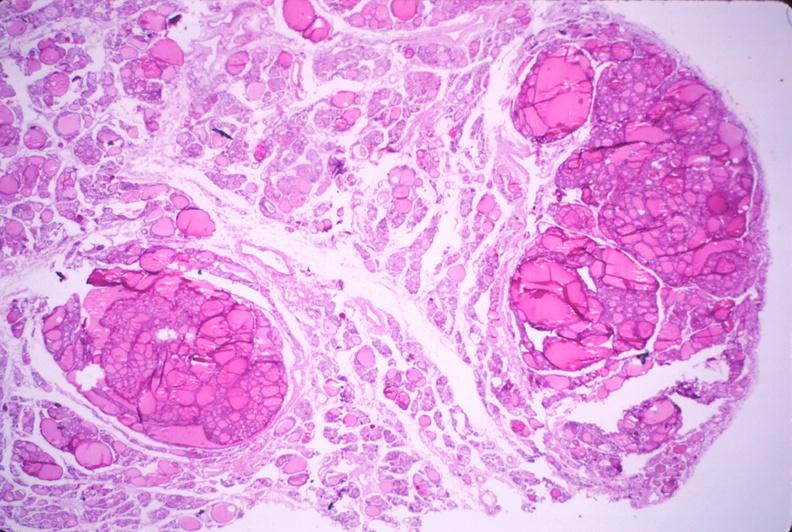what is present?
Answer the question using a single word or phrase. Endocrine 